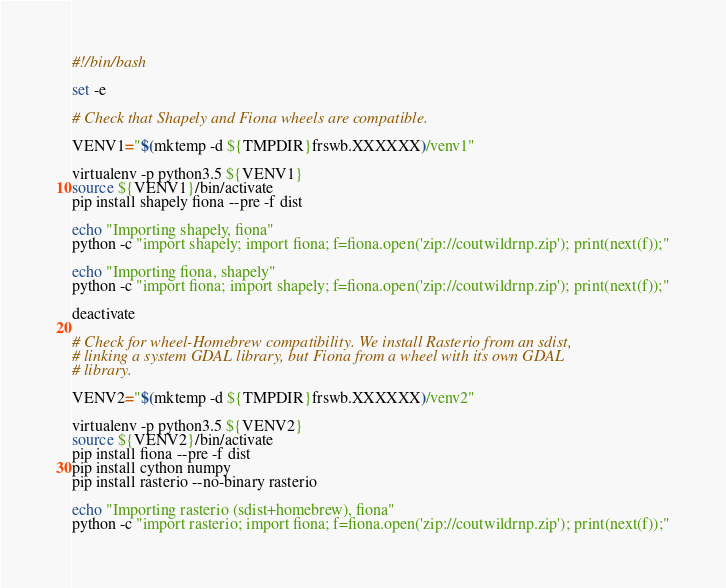Convert code to text. <code><loc_0><loc_0><loc_500><loc_500><_Bash_>#!/bin/bash

set -e

# Check that Shapely and Fiona wheels are compatible.

VENV1="$(mktemp -d ${TMPDIR}frswb.XXXXXX)/venv1"

virtualenv -p python3.5 ${VENV1}
source ${VENV1}/bin/activate
pip install shapely fiona --pre -f dist

echo "Importing shapely, fiona"
python -c "import shapely; import fiona; f=fiona.open('zip://coutwildrnp.zip'); print(next(f));"

echo "Importing fiona, shapely"
python -c "import fiona; import shapely; f=fiona.open('zip://coutwildrnp.zip'); print(next(f));"

deactivate

# Check for wheel-Homebrew compatibility. We install Rasterio from an sdist,
# linking a system GDAL library, but Fiona from a wheel with its own GDAL
# library.

VENV2="$(mktemp -d ${TMPDIR}frswb.XXXXXX)/venv2"

virtualenv -p python3.5 ${VENV2}
source ${VENV2}/bin/activate
pip install fiona --pre -f dist
pip install cython numpy
pip install rasterio --no-binary rasterio

echo "Importing rasterio (sdist+homebrew), fiona"
python -c "import rasterio; import fiona; f=fiona.open('zip://coutwildrnp.zip'); print(next(f));"
</code> 